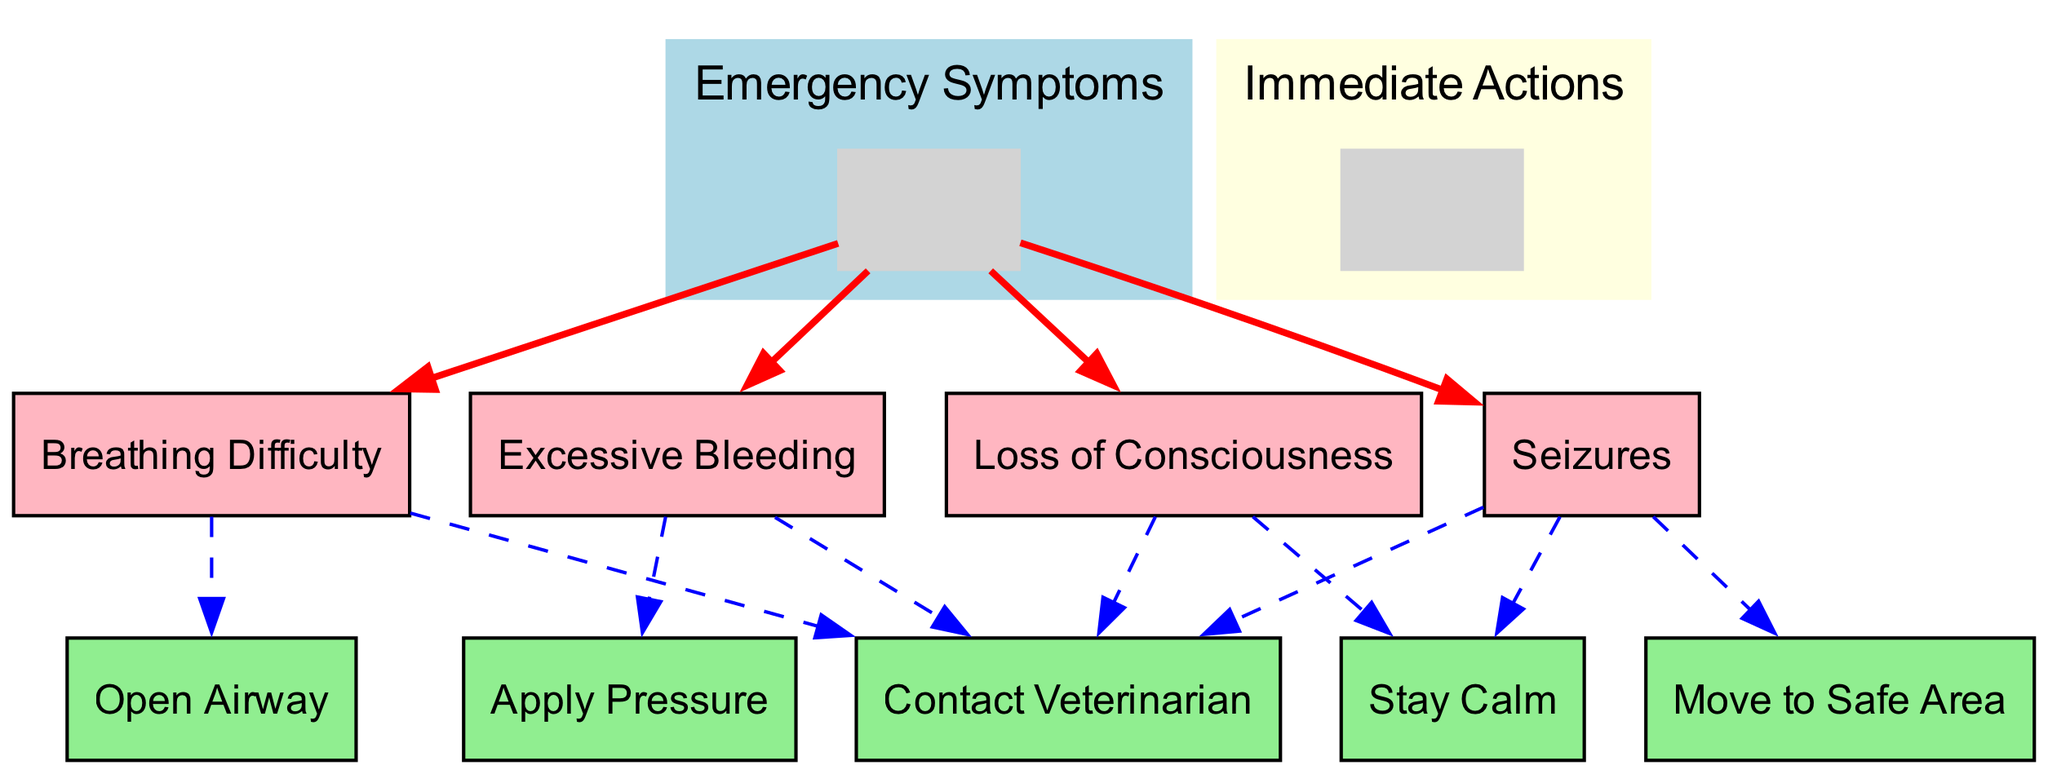What are the four emergency symptoms listed in the diagram? The diagram lists four emergency symptoms: Breathing Difficulty, Excessive Bleeding, Seizures, and Loss of Consciousness.
Answer: Breathing Difficulty, Excessive Bleeding, Seizures, Loss of Consciousness How many immediate actions are specified for each symptom? The diagram indicates various immediate actions for each symptom. Breathing Difficulty has 2 actions, Excessive Bleeding has 2 actions, Seizures has 3 actions, and Loss of Consciousness has 2 actions. The sum is 9 actions in total.
Answer: 9 Which immediate action is recommended for breathing difficulty? The diagram indicates that for Breathing Difficulty, the recommended immediate actions are to Open Airway and Contact Veterinarian.
Answer: Open Airway and Contact Veterinarian What is the immediate action for seizures? The diagram shows that the immediate actions for seizures are to Stay Calm, Move to Safe Area, and Contact Veterinarian.
Answer: Stay Calm, Move to Safe Area, Contact Veterinarian If a pet is experiencing excessive bleeding, which immediate action should be taken first? According to the diagram, the first immediate action for Excessive Bleeding is to Apply Pressure, followed by contacting the veterinarian.
Answer: Apply Pressure Are there any immediate actions that are common to more than one symptom? Yes, the action to Contact Veterinarian is common to Excessive Bleeding, Seizures, and Loss of Consciousness, indicating the importance of seeking professional help for various symptoms.
Answer: Contact Veterinarian Which symptoms require the immediate action of staying calm? The symptoms that require the immediate action of Staying Calm are Seizures and Loss of Consciousness, emphasizing the importance of remaining composed in these situations.
Answer: Seizures, Loss of Consciousness How can a pet owner prepare for a pet experiencing loss of consciousness? The diagram suggests that a pet owner should Stay Calm and Contact Veterinarian if their pet experiences loss of consciousness.
Answer: Stay Calm, Contact Veterinarian 